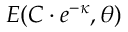<formula> <loc_0><loc_0><loc_500><loc_500>E ( C \cdot e ^ { - { \kappa } } , { \theta } )</formula> 